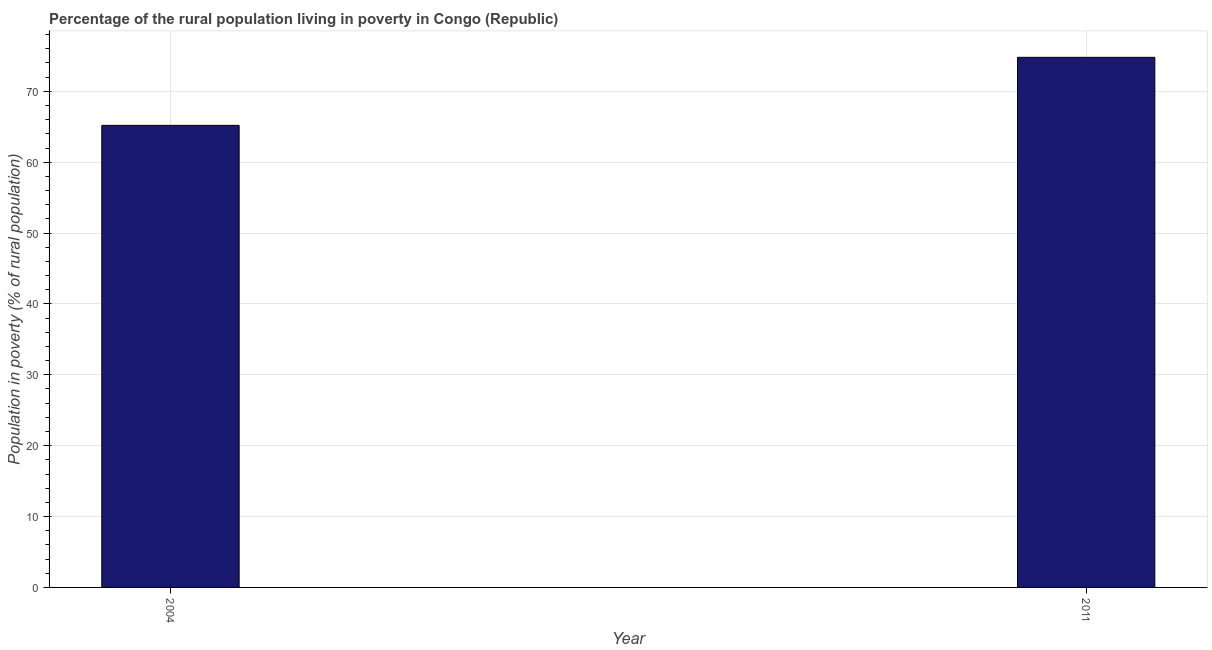Does the graph contain grids?
Ensure brevity in your answer.  Yes. What is the title of the graph?
Make the answer very short. Percentage of the rural population living in poverty in Congo (Republic). What is the label or title of the Y-axis?
Keep it short and to the point. Population in poverty (% of rural population). What is the percentage of rural population living below poverty line in 2004?
Keep it short and to the point. 65.2. Across all years, what is the maximum percentage of rural population living below poverty line?
Ensure brevity in your answer.  74.8. Across all years, what is the minimum percentage of rural population living below poverty line?
Provide a short and direct response. 65.2. In which year was the percentage of rural population living below poverty line maximum?
Your answer should be very brief. 2011. What is the sum of the percentage of rural population living below poverty line?
Offer a very short reply. 140. What is the average percentage of rural population living below poverty line per year?
Give a very brief answer. 70. Do a majority of the years between 2011 and 2004 (inclusive) have percentage of rural population living below poverty line greater than 54 %?
Provide a short and direct response. No. What is the ratio of the percentage of rural population living below poverty line in 2004 to that in 2011?
Ensure brevity in your answer.  0.87. Is the percentage of rural population living below poverty line in 2004 less than that in 2011?
Your answer should be compact. Yes. In how many years, is the percentage of rural population living below poverty line greater than the average percentage of rural population living below poverty line taken over all years?
Offer a very short reply. 1. How many bars are there?
Your answer should be compact. 2. Are all the bars in the graph horizontal?
Make the answer very short. No. Are the values on the major ticks of Y-axis written in scientific E-notation?
Offer a terse response. No. What is the Population in poverty (% of rural population) in 2004?
Provide a succinct answer. 65.2. What is the Population in poverty (% of rural population) in 2011?
Provide a succinct answer. 74.8. What is the difference between the Population in poverty (% of rural population) in 2004 and 2011?
Make the answer very short. -9.6. What is the ratio of the Population in poverty (% of rural population) in 2004 to that in 2011?
Your response must be concise. 0.87. 